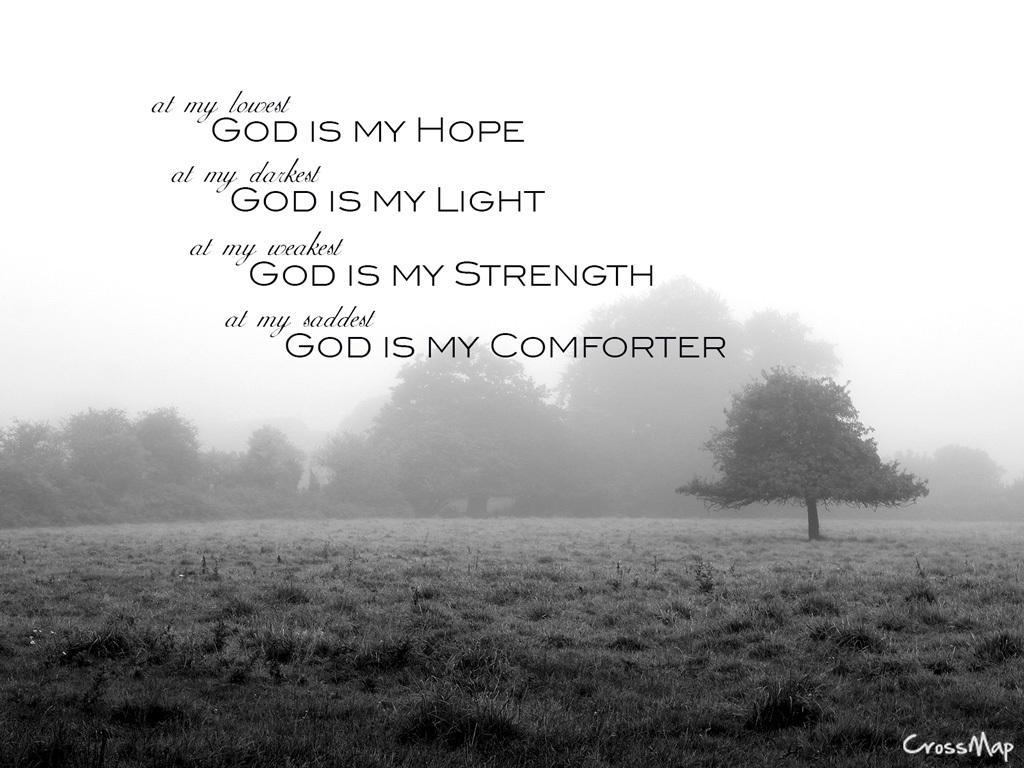What type of terrain is visible in the image? There is grassy land in the image. What type of vegetation can be seen in the image? There are trees in the image. Is there any text present in the image? Yes, there is text written on the image. What type of church is depicted in the image? There is no church present in the image; it features grassy land, trees, and text. 